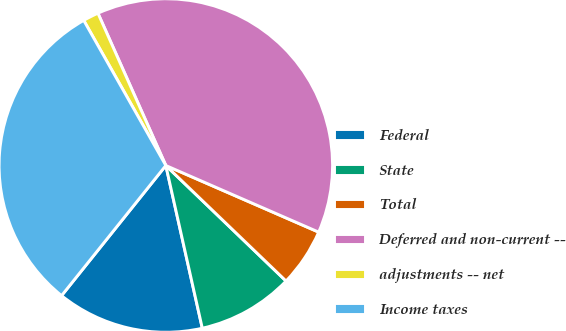Convert chart to OTSL. <chart><loc_0><loc_0><loc_500><loc_500><pie_chart><fcel>Federal<fcel>State<fcel>Total<fcel>Deferred and non-current --<fcel>adjustments -- net<fcel>Income taxes<nl><fcel>14.26%<fcel>9.31%<fcel>5.64%<fcel>38.22%<fcel>1.52%<fcel>31.06%<nl></chart> 